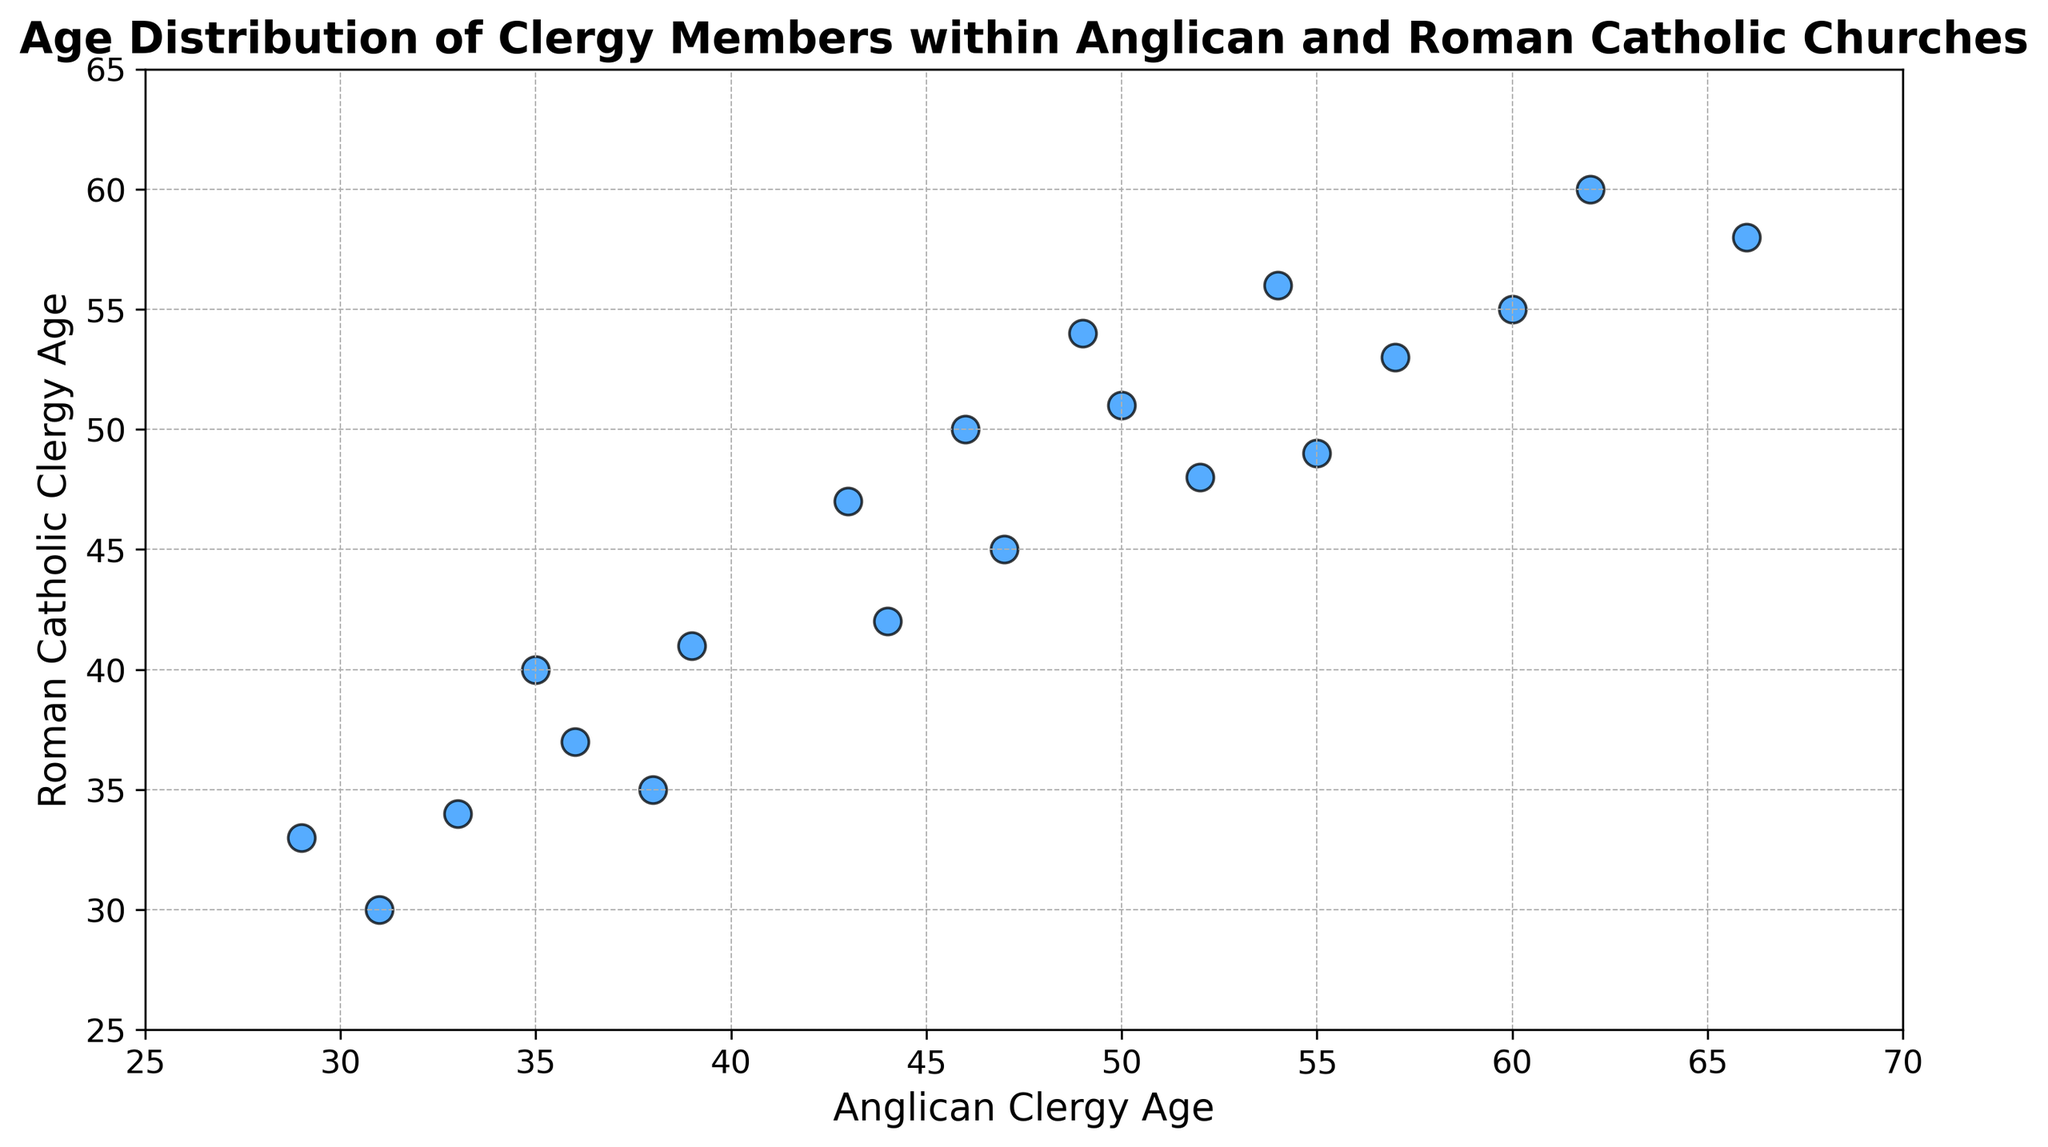What's the youngest age for the Anglican clergy members? By looking at the x-axis, locate the smallest value among the Anglican clergy members' ages.
Answer: 29 Which Anglican clergy member age corresponds with a Roman Catholic clergy member aged 51? Find the data point on the plot where the Roman Catholic clergy member age (y-axis) is 51, check its corresponding Anglican clergy member age on the x-axis.
Answer: 50 Do most Anglican clergy members tend to be younger or older than Roman Catholic clergy members? Compare the general trend of the data points; if more points are above the diagonal line y = x, it indicates that Roman Catholic clergy members are generally older.
Answer: Older What is the average age of Anglican and Roman Catholic clergy members? Add all the ages for the Anglican clergy members and divide by the number of data points (20). Do the same for Roman Catholic clergy members. 
Step-by-Step:
Anglican: (35 + 46 + 60 + 29 + 52 + 38 + 43 + 57 + 62 + 44 + 39 + 50 + 36 + 55 + 49 + 33 + 66 + 47 + 54 + 31) / 20 = 46.1
Roman Catholic: (40 + 50 + 55 + 33 + 48 + 35 + 47 + 53 + 60 + 42 + 41 + 51 + 37 + 49 + 54 + 34 + 58 + 45 + 56 + 30) / 20 = 45.35
Answer: 46.1 (Anglican), 45.35 (Roman Catholic) How many clergy members are below 40 years of age in both denominations? Count the data points where both x and y values are below 40.
Answer: 3 What's the range of ages for Roman Catholic clergy members? Identify the minimum and maximum ages for Roman Catholic clergy members and calculate the difference.
Step-by-Step:
Min: 30, Max: 60, Range: 60 - 30 = 30
Answer: 30 Does the oldest Anglican clergy member have a Roman Catholic counterpart who is older or younger? Locate the data point representing the oldest Anglican clergy member (x=66), check the corresponding Roman Catholic age (y=58), and compare.
Answer: Younger Are there any clergy members of the same age in both denominations? Check if any data points lie exactly on the diagonal line y = x, implying equal ages for both.
Answer: No Which age group has a more significant variance, Anglican or Roman Catholic clergy members? Compare the spread of ages (how widely values differ from the mean) using visual width of the data distribution for each group.
Step-by-Step:
Assess the spread visually; Anglican ages appear more varied as they range from 29 to 66, while Roman Catholic ages range from 30 to 60.
Answer: Anglican clergy members 